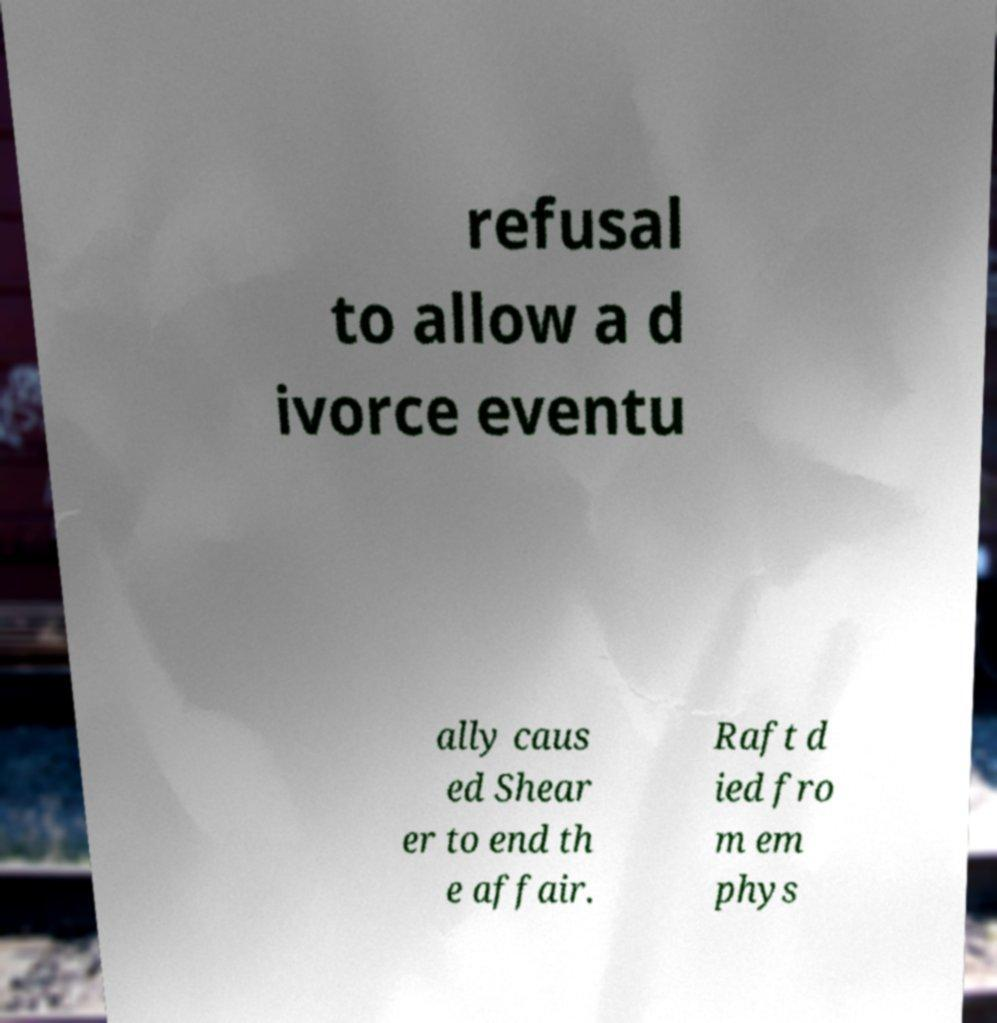For documentation purposes, I need the text within this image transcribed. Could you provide that? refusal to allow a d ivorce eventu ally caus ed Shear er to end th e affair. Raft d ied fro m em phys 